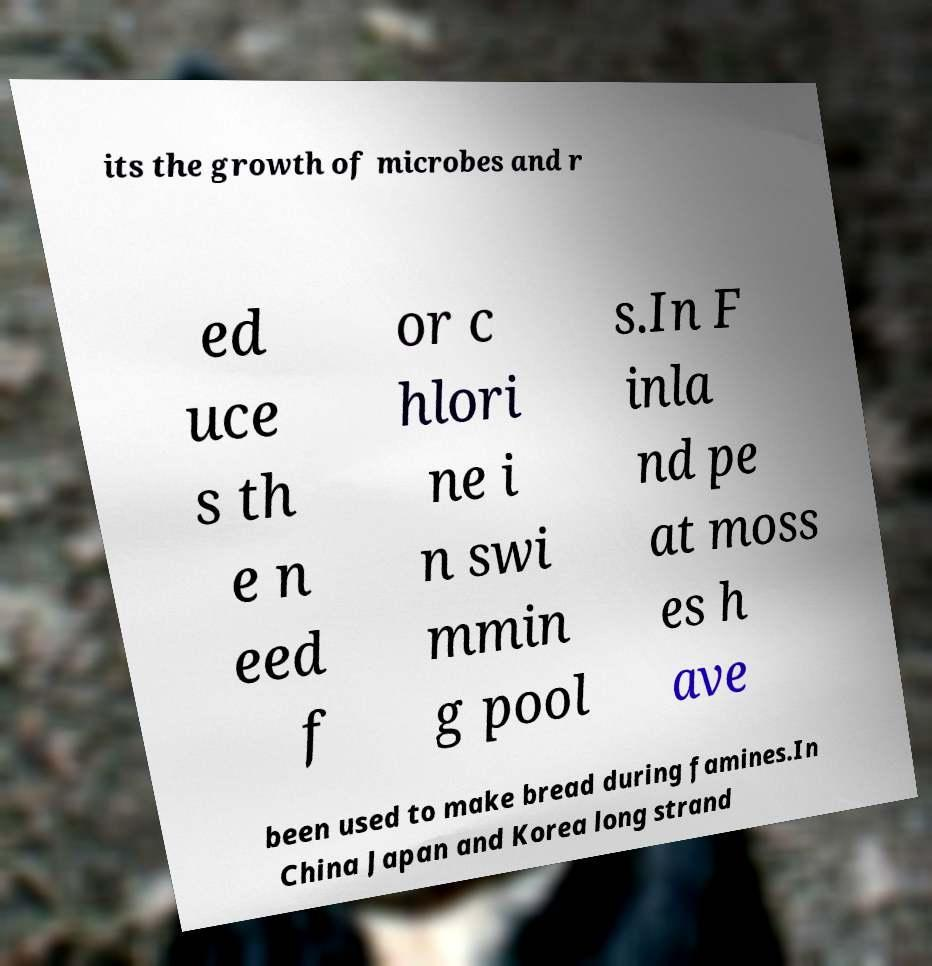There's text embedded in this image that I need extracted. Can you transcribe it verbatim? its the growth of microbes and r ed uce s th e n eed f or c hlori ne i n swi mmin g pool s.In F inla nd pe at moss es h ave been used to make bread during famines.In China Japan and Korea long strand 